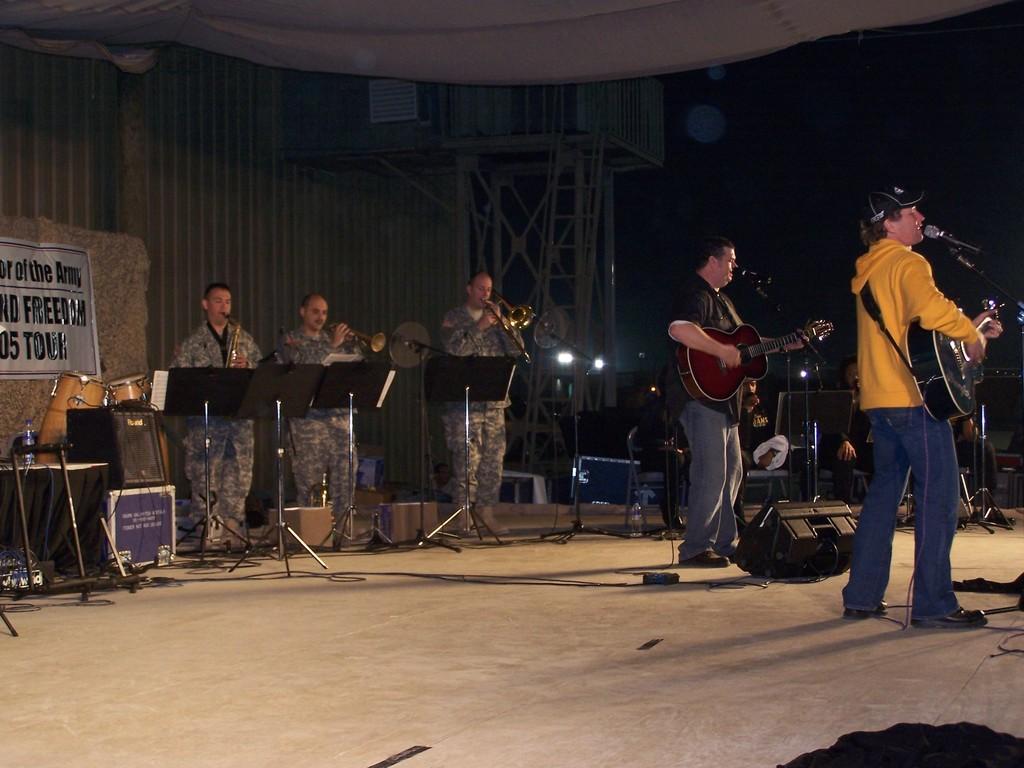Please provide a concise description of this image. In this picture three army officers are playing musical instruments and to the right side of the image there are people playing guitar and singing through a mic placed in front of them. This picture is clicked in a concert. 